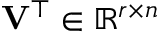Convert formula to latex. <formula><loc_0><loc_0><loc_500><loc_500>V ^ { \top } \in \mathbb { R } ^ { r \times n }</formula> 